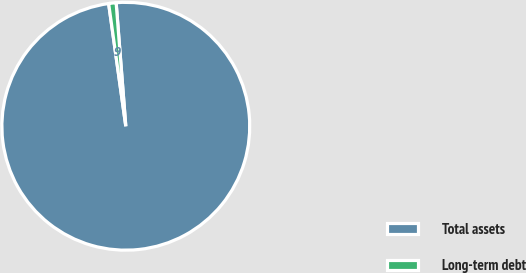Convert chart to OTSL. <chart><loc_0><loc_0><loc_500><loc_500><pie_chart><fcel>Total assets<fcel>Long-term debt<nl><fcel>99.03%<fcel>0.97%<nl></chart> 